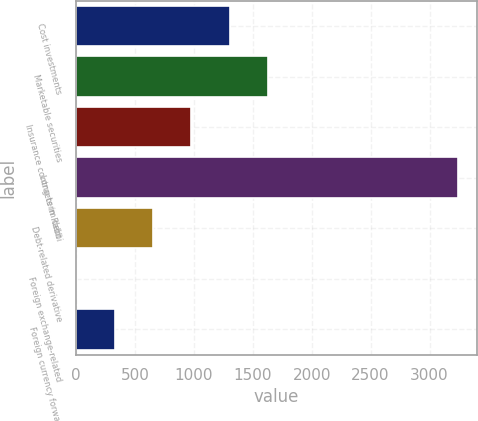<chart> <loc_0><loc_0><loc_500><loc_500><bar_chart><fcel>Cost investments<fcel>Marketable securities<fcel>Insurance contracts in Rabbi<fcel>Long-term debt<fcel>Debt-related derivative<fcel>Foreign exchange-related<fcel>Foreign currency forward<nl><fcel>1302.6<fcel>1626<fcel>979.2<fcel>3243<fcel>655.8<fcel>9<fcel>332.4<nl></chart> 